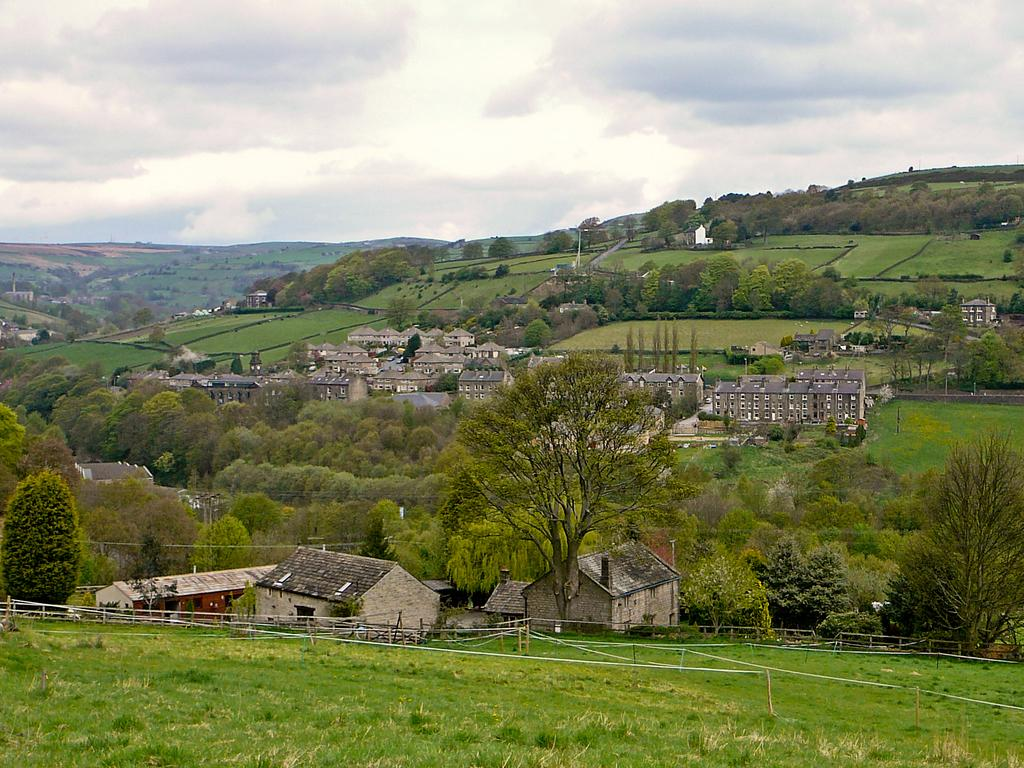What type of landscape is depicted in the image? The image features hills. What structures can be seen on the hills? There are buildings and trees on the hills. What type of vegetation is present on the hills? There is grass on the hills. What is at the bottom of the hills? There is fencing at the bottom of the hills. What is visible at the top of the image? The sky is visible at the top of the image. How many attempts were made to climb the pin in the image? There is no pin present in the image, and therefore no attempts to climb it can be observed. 